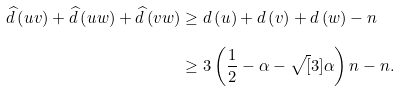<formula> <loc_0><loc_0><loc_500><loc_500>\widehat { d } \left ( u v \right ) + \widehat { d } \left ( u w \right ) + \widehat { d } \left ( v w \right ) & \geq d \left ( u \right ) + d \left ( v \right ) + d \left ( w \right ) - n \\ & \geq 3 \left ( \frac { 1 } { 2 } - \alpha - \sqrt { [ } 3 ] { \alpha } \right ) n - n .</formula> 